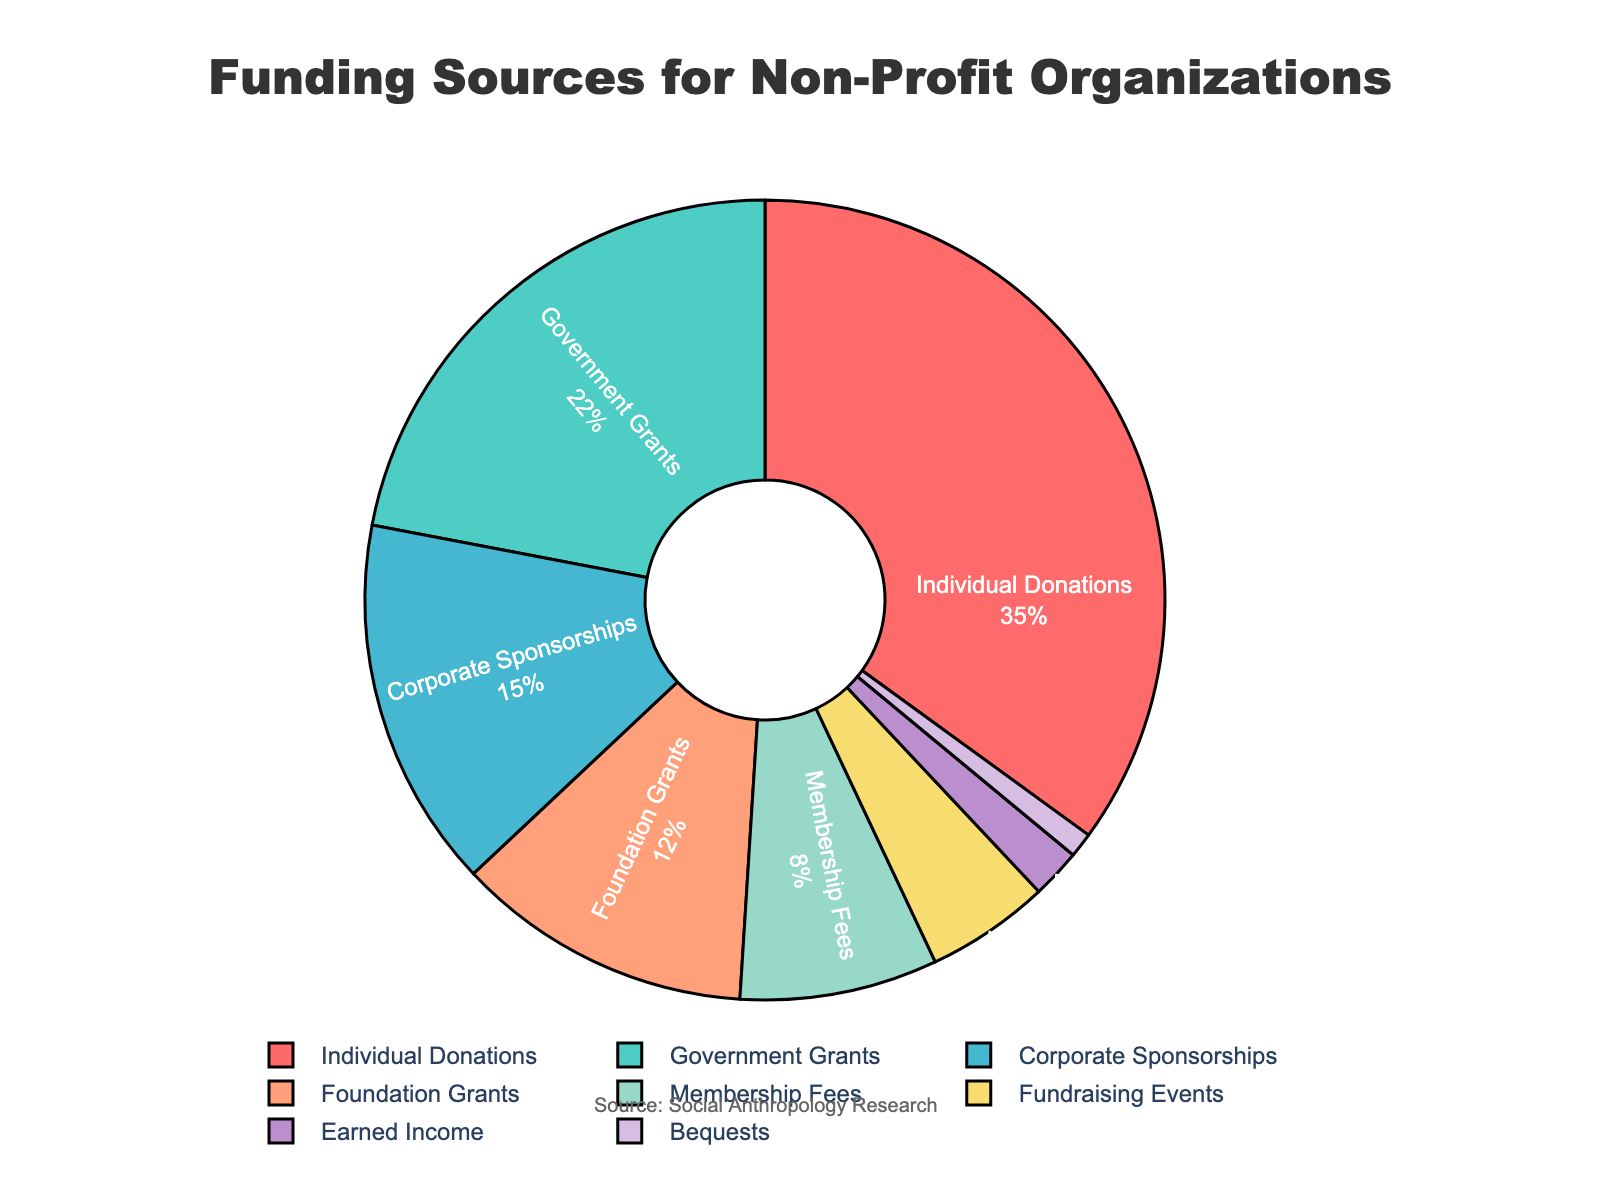What funding source contributes the highest percentage? The funding source with the highest percentage can be identified by looking for the largest segment in the pie chart. Individual Donations account for 35%, which is the highest.
Answer: Individual Donations Which funding source has a smaller percentage: Fundraising Events or Earned Income? By comparing the sizes or percentages of the segments for Fundraising Events and Earned Income, Fundraising Events has 5% while Earned Income has 2%. Thus, Earned Income has a smaller percentage.
Answer: Earned Income What is the total percentage contributed by Government Grants and Corporate Sponsorships? Adding the percentages for Government Grants (22%) and Corporate Sponsorships (15%), the total is 22% + 15% = 37%.
Answer: 37% How much more does Individual Donations contribute compared to Foundation Grants? Subtracting the percentage of Foundation Grants (12%) from Individual Donations (35%), the difference is 35% - 12% = 23%.
Answer: 23% Is the combined contribution of Membership Fees and Earned Income greater than that of Foundation Grants? Adding the percentages for Membership Fees (8%) and Earned Income (2%), the total is 8% + 2% = 10%, which is less than Foundation Grants' 12%.
Answer: No Which funding source is represented by the blue segment? The pie chart has a specific color assigned to each segment. By identifying and matching the blue color segment, which corresponds to Corporate Sponsorships (15%).
Answer: Corporate Sponsorships What is the mean percentage contributed by Individual Donations, Government Grants, and Foundation Grants? Adding the percentages for Individual Donations (35%), Government Grants (22%), and Foundation Grants (12%), the total is 35% + 22% + 12% = 69%. Dividing by 3 funding sources, the mean is 69% / 3 = 23%.
Answer: 23% What percentage more does Government Grants contribute compared to Membership Fees? Subtracting the percentage of Membership Fees (8%) from Government Grants (22%), the difference is 22% - 8% = 14%.
Answer: 14% Do Corporate Sponsorships and Bequests together account for more than 15% of the total funding? Adding the percentages for Corporate Sponsorships (15%) and Bequests (1%), the total is 15% + 1% = 16%, which is more than 15%.
Answer: Yes Which funding source has a smaller percentage: Membership Fees or Fundraising Events? Comparing the sizes or percentages of the segments for Membership Fees (8%) and Fundraising Events (5%), Fundraising Events has a smaller percentage.
Answer: Fundraising Events 